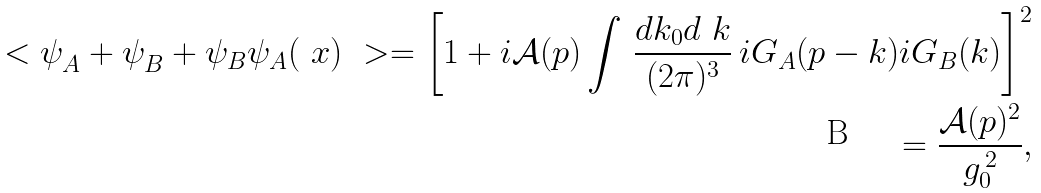Convert formula to latex. <formula><loc_0><loc_0><loc_500><loc_500>\ < \psi _ { A } ^ { \ } + \psi _ { B } ^ { \ } + \psi _ { B } \psi _ { A } ( \ x ) \ > = \left [ 1 + i \mathcal { A } ( p ) \int \, \frac { d k _ { 0 } d \ k } { ( 2 \pi ) ^ { 3 } } \, i G _ { A } ( p - k ) i G _ { B } ( k ) \right ] ^ { 2 } \\ = \frac { \mathcal { A } ( p ) ^ { 2 } } { g _ { 0 } ^ { \, 2 } } ,</formula> 